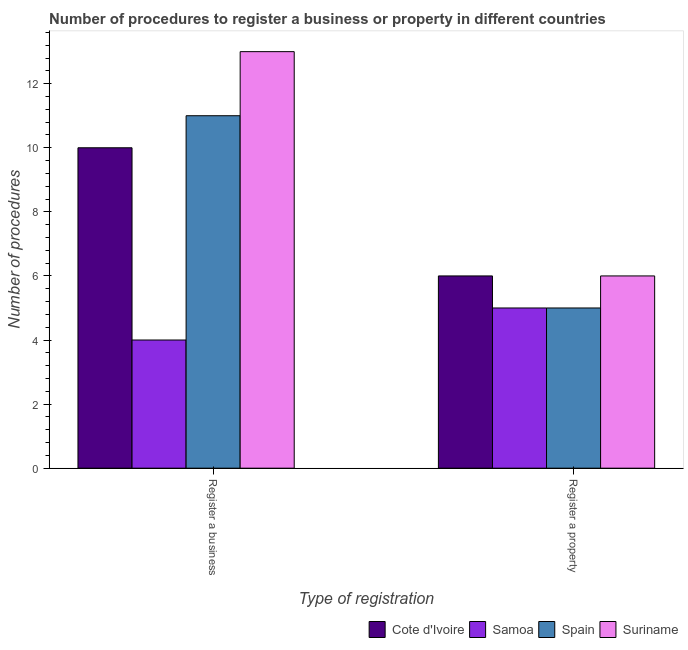How many groups of bars are there?
Offer a terse response. 2. How many bars are there on the 2nd tick from the left?
Provide a short and direct response. 4. What is the label of the 2nd group of bars from the left?
Offer a very short reply. Register a property. What is the number of procedures to register a business in Suriname?
Your response must be concise. 13. Across all countries, what is the maximum number of procedures to register a business?
Make the answer very short. 13. Across all countries, what is the minimum number of procedures to register a property?
Provide a short and direct response. 5. In which country was the number of procedures to register a business maximum?
Make the answer very short. Suriname. In which country was the number of procedures to register a property minimum?
Provide a short and direct response. Samoa. What is the total number of procedures to register a property in the graph?
Make the answer very short. 22. What is the difference between the number of procedures to register a property in Suriname and that in Cote d'Ivoire?
Give a very brief answer. 0. What is the difference between the number of procedures to register a property in Samoa and the number of procedures to register a business in Suriname?
Give a very brief answer. -8. In how many countries, is the number of procedures to register a property greater than the average number of procedures to register a property taken over all countries?
Make the answer very short. 2. What does the 3rd bar from the left in Register a property represents?
Provide a succinct answer. Spain. What does the 1st bar from the right in Register a business represents?
Make the answer very short. Suriname. Are all the bars in the graph horizontal?
Keep it short and to the point. No. How many countries are there in the graph?
Your response must be concise. 4. Are the values on the major ticks of Y-axis written in scientific E-notation?
Make the answer very short. No. Does the graph contain any zero values?
Provide a short and direct response. No. Where does the legend appear in the graph?
Give a very brief answer. Bottom right. How many legend labels are there?
Make the answer very short. 4. How are the legend labels stacked?
Ensure brevity in your answer.  Horizontal. What is the title of the graph?
Ensure brevity in your answer.  Number of procedures to register a business or property in different countries. Does "Malaysia" appear as one of the legend labels in the graph?
Keep it short and to the point. No. What is the label or title of the X-axis?
Your answer should be compact. Type of registration. What is the label or title of the Y-axis?
Keep it short and to the point. Number of procedures. What is the Number of procedures of Cote d'Ivoire in Register a property?
Make the answer very short. 6. What is the Number of procedures in Samoa in Register a property?
Ensure brevity in your answer.  5. Across all Type of registration, what is the maximum Number of procedures in Cote d'Ivoire?
Your answer should be very brief. 10. Across all Type of registration, what is the maximum Number of procedures of Samoa?
Offer a terse response. 5. Across all Type of registration, what is the minimum Number of procedures in Spain?
Ensure brevity in your answer.  5. Across all Type of registration, what is the minimum Number of procedures of Suriname?
Your answer should be very brief. 6. What is the total Number of procedures of Cote d'Ivoire in the graph?
Offer a terse response. 16. What is the total Number of procedures in Spain in the graph?
Offer a terse response. 16. What is the total Number of procedures in Suriname in the graph?
Your answer should be compact. 19. What is the difference between the Number of procedures of Cote d'Ivoire in Register a business and that in Register a property?
Offer a terse response. 4. What is the difference between the Number of procedures of Samoa in Register a business and that in Register a property?
Make the answer very short. -1. What is the difference between the Number of procedures in Suriname in Register a business and that in Register a property?
Your answer should be very brief. 7. What is the difference between the Number of procedures of Cote d'Ivoire in Register a business and the Number of procedures of Spain in Register a property?
Offer a very short reply. 5. What is the difference between the Number of procedures in Samoa in Register a business and the Number of procedures in Spain in Register a property?
Keep it short and to the point. -1. What is the average Number of procedures in Suriname per Type of registration?
Your answer should be compact. 9.5. What is the difference between the Number of procedures in Cote d'Ivoire and Number of procedures in Samoa in Register a business?
Provide a short and direct response. 6. What is the difference between the Number of procedures in Cote d'Ivoire and Number of procedures in Samoa in Register a property?
Your answer should be compact. 1. What is the difference between the Number of procedures in Cote d'Ivoire and Number of procedures in Spain in Register a property?
Your answer should be very brief. 1. What is the difference between the Number of procedures in Samoa and Number of procedures in Suriname in Register a property?
Ensure brevity in your answer.  -1. What is the ratio of the Number of procedures of Cote d'Ivoire in Register a business to that in Register a property?
Your answer should be very brief. 1.67. What is the ratio of the Number of procedures of Samoa in Register a business to that in Register a property?
Your response must be concise. 0.8. What is the ratio of the Number of procedures of Spain in Register a business to that in Register a property?
Make the answer very short. 2.2. What is the ratio of the Number of procedures in Suriname in Register a business to that in Register a property?
Give a very brief answer. 2.17. What is the difference between the highest and the second highest Number of procedures of Spain?
Provide a short and direct response. 6. What is the difference between the highest and the lowest Number of procedures of Suriname?
Give a very brief answer. 7. 